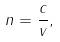Convert formula to latex. <formula><loc_0><loc_0><loc_500><loc_500>n = { \frac { c } { v } } ,</formula> 